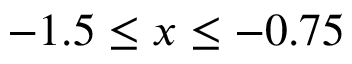Convert formula to latex. <formula><loc_0><loc_0><loc_500><loc_500>- 1 . 5 \leq x \leq - 0 . 7 5</formula> 